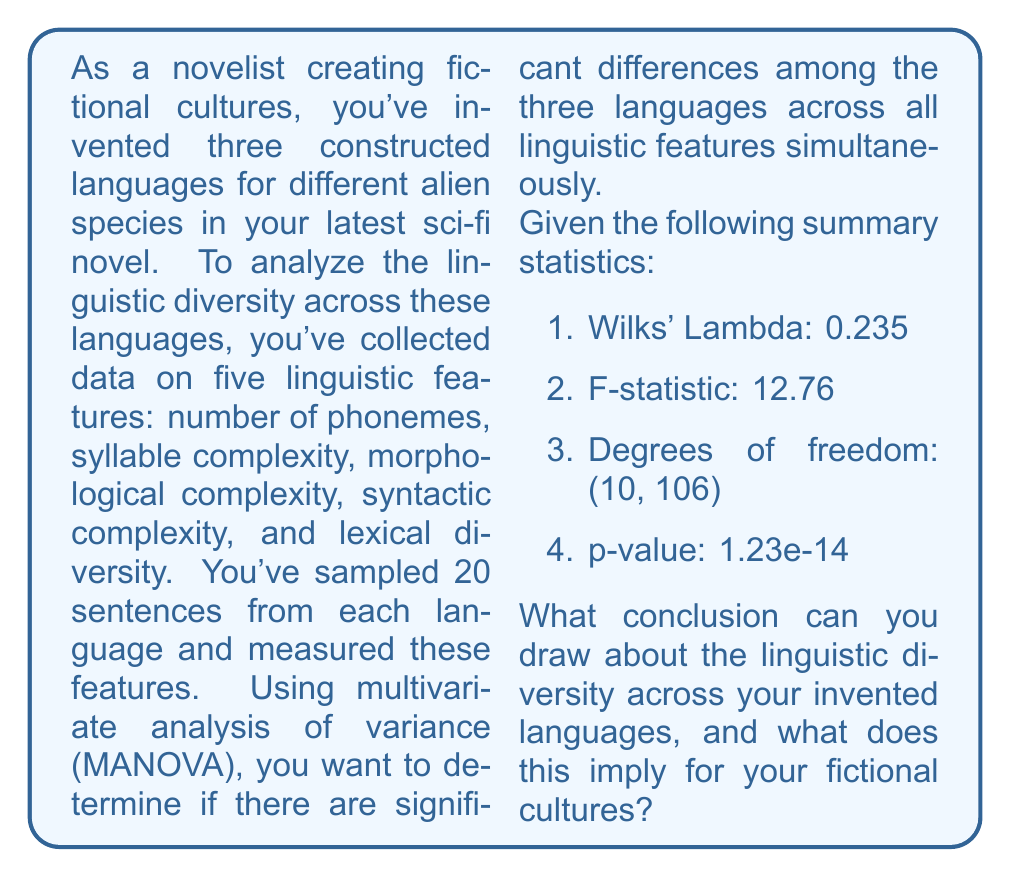What is the answer to this math problem? To interpret the results of the MANOVA test, we need to understand each component of the output:

1. Wilks' Lambda: This is a test statistic used in MANOVA. It ranges from 0 to 1, where values closer to 0 indicate greater differences between groups. Our value of 0.235 suggests substantial differences between the languages.

2. F-statistic: This is used to test the null hypothesis that there are no differences between the groups. A larger F-statistic indicates stronger evidence against the null hypothesis.

3. Degrees of freedom: These are (10, 106), which correspond to the numerator and denominator degrees of freedom for the F-distribution.

4. p-value: This is the probability of obtaining test results at least as extreme as the observed results, assuming that the null hypothesis is true. A very small p-value (typically < 0.05) leads to rejecting the null hypothesis.

In this case, the p-value is extremely small (1.23e-14 or 0.0000000000000123), which is much less than the conventional significance level of 0.05.

To interpret these results:

1. The small Wilks' Lambda (0.235) suggests substantial differences between the languages across the linguistic features.

2. The large F-statistic (12.76) and very small p-value (1.23e-14) provide strong evidence against the null hypothesis of no differences between the languages.

3. We can conclude that there are statistically significant differences among the three constructed languages across the five linguistic features simultaneously.

For the novelist, this implies that the invented languages for the different alien species are indeed linguistically diverse. This statistical evidence supports the creation of distinct linguistic profiles for each alien culture in the fictional universe, enhancing the richness and believability of the constructed worlds.
Answer: Significant linguistic diversity exists among the three invented languages (p < 0.001), supporting distinct linguistic profiles for each fictional alien culture. 